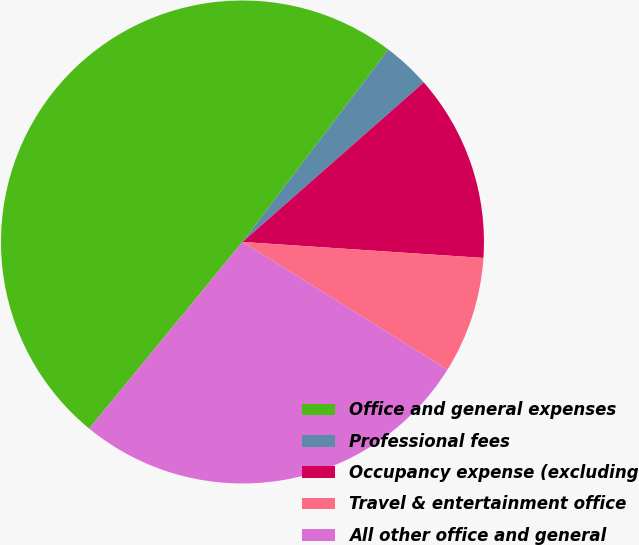<chart> <loc_0><loc_0><loc_500><loc_500><pie_chart><fcel>Office and general expenses<fcel>Professional fees<fcel>Occupancy expense (excluding<fcel>Travel & entertainment office<fcel>All other office and general<nl><fcel>49.38%<fcel>3.19%<fcel>12.54%<fcel>7.81%<fcel>27.08%<nl></chart> 